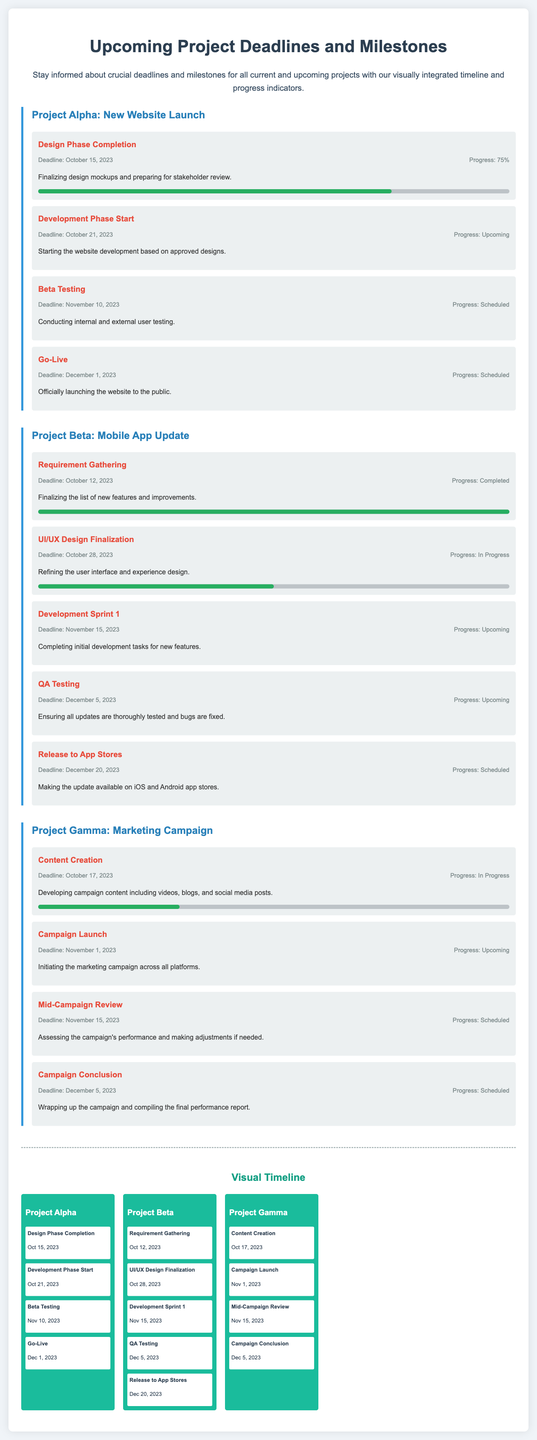What is the deadline for the Design Phase Completion of Project Alpha? The deadline for this milestone is directly mentioned in the document.
Answer: October 15, 2023 What is the progress percentage of the Requirement Gathering for Project Beta? The progress is specified in the milestone details for this project.
Answer: 100% What is the major milestone that follows the UI/UX Design Finalization in Project Beta? This requires understanding the sequence of milestones listed in the document for this project.
Answer: Development Sprint 1 When is the Campaign Launch for Project Gamma scheduled? This information is provided in the corresponding milestone for Project Gamma.
Answer: November 1, 2023 What is the progress of the Content Creation milestone in Project Gamma? The progress percentage is mentioned in the document under the respective milestone.
Answer: 30% Which project has the earliest deadline listed in the document? This requires comparing the deadlines provided for all projects to identify the earliest one.
Answer: Project Beta How many milestones are scheduled for Project Alpha? This involves counting the number of distinct milestone sections under Project Alpha.
Answer: 4 What color is the progress indicator for the Go-Live milestone in Project Alpha? The visual representation in the document specifies the color used for the progress bar.
Answer: Green What phrase describes the purpose of this advertisement document? This is summarized in the descriptive paragraph at the beginning of the document.
Answer: Stay informed about crucial deadlines and milestones 